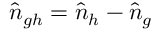Convert formula to latex. <formula><loc_0><loc_0><loc_500><loc_500>\hat { n } _ { g h } = \hat { n } _ { h } - \hat { n } _ { g }</formula> 